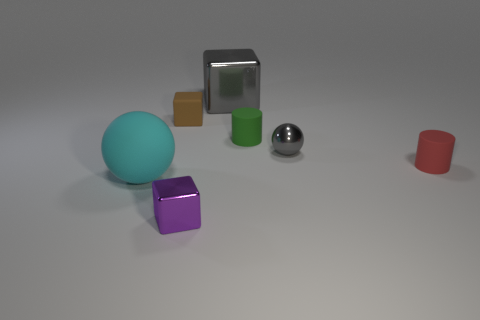Add 2 brown blocks. How many objects exist? 9 Subtract all spheres. How many objects are left? 5 Add 1 green cylinders. How many green cylinders exist? 2 Subtract 1 purple cubes. How many objects are left? 6 Subtract all large blue matte cylinders. Subtract all tiny things. How many objects are left? 2 Add 3 large cyan matte balls. How many large cyan matte balls are left? 4 